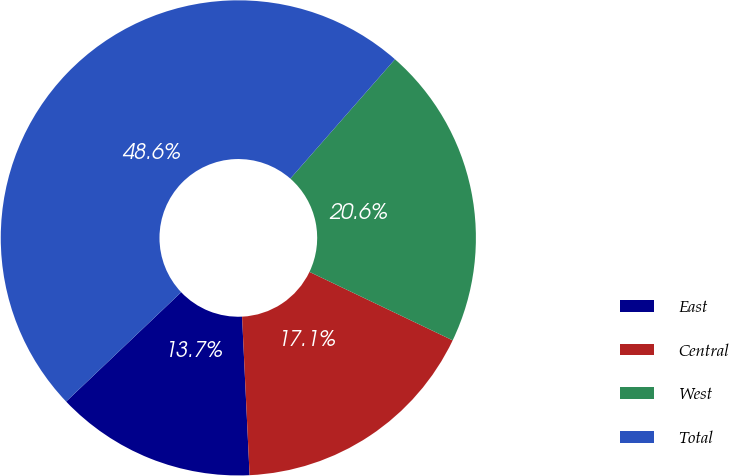Convert chart. <chart><loc_0><loc_0><loc_500><loc_500><pie_chart><fcel>East<fcel>Central<fcel>West<fcel>Total<nl><fcel>13.66%<fcel>17.15%<fcel>20.64%<fcel>48.56%<nl></chart> 